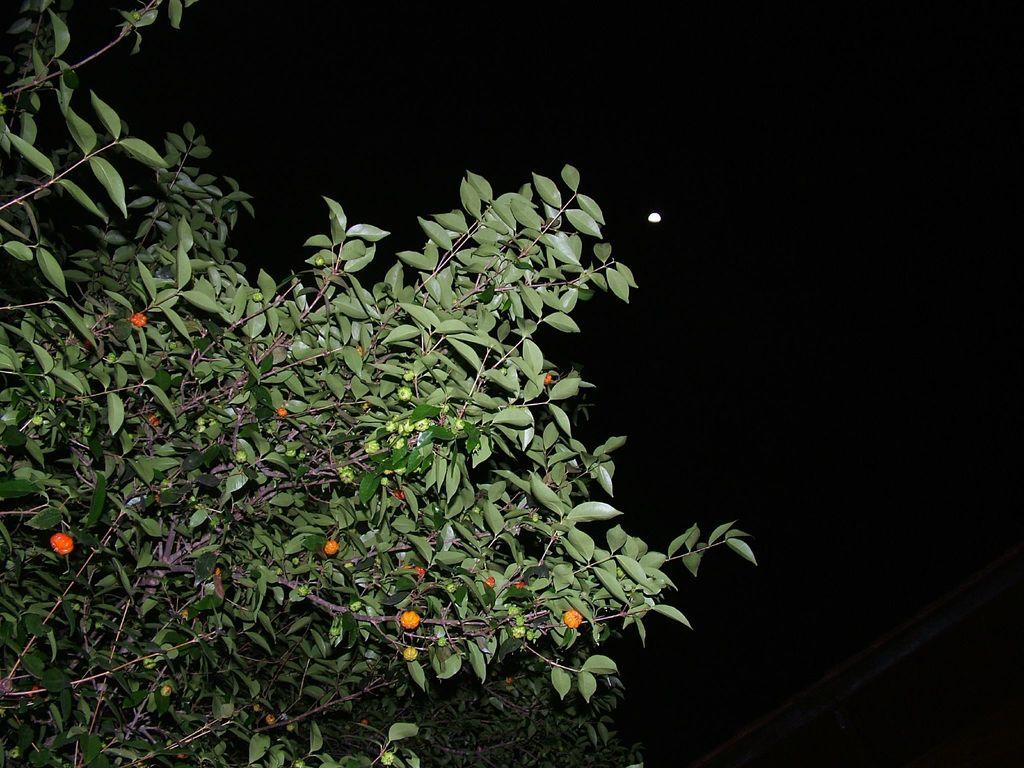What type of vegetation is visible in the image? There are trees in the image. What is the color of the background in the image? The background of the image is dark. Can you see any ants crawling on the trees in the image? There is no indication of ants in the image; it only features trees and a dark background. Is there a camera visible in the image? There is no camera present in the image. Is there a rabbit visible in the image? There is no rabbit present in the image. 